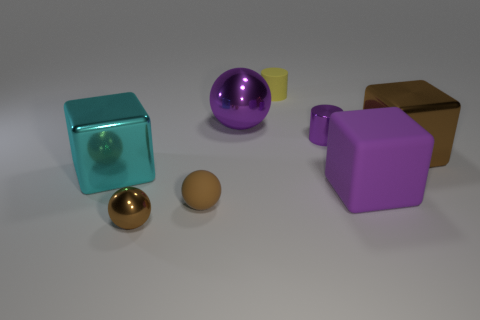Subtract all purple rubber blocks. How many blocks are left? 2 Subtract all cyan cylinders. How many purple blocks are left? 1 Add 2 brown metal things. How many objects exist? 10 Subtract all brown balls. How many balls are left? 1 Subtract 0 green cylinders. How many objects are left? 8 Subtract all cylinders. How many objects are left? 6 Subtract 1 spheres. How many spheres are left? 2 Subtract all green cubes. Subtract all red balls. How many cubes are left? 3 Subtract all blocks. Subtract all small matte cylinders. How many objects are left? 4 Add 3 purple cubes. How many purple cubes are left? 4 